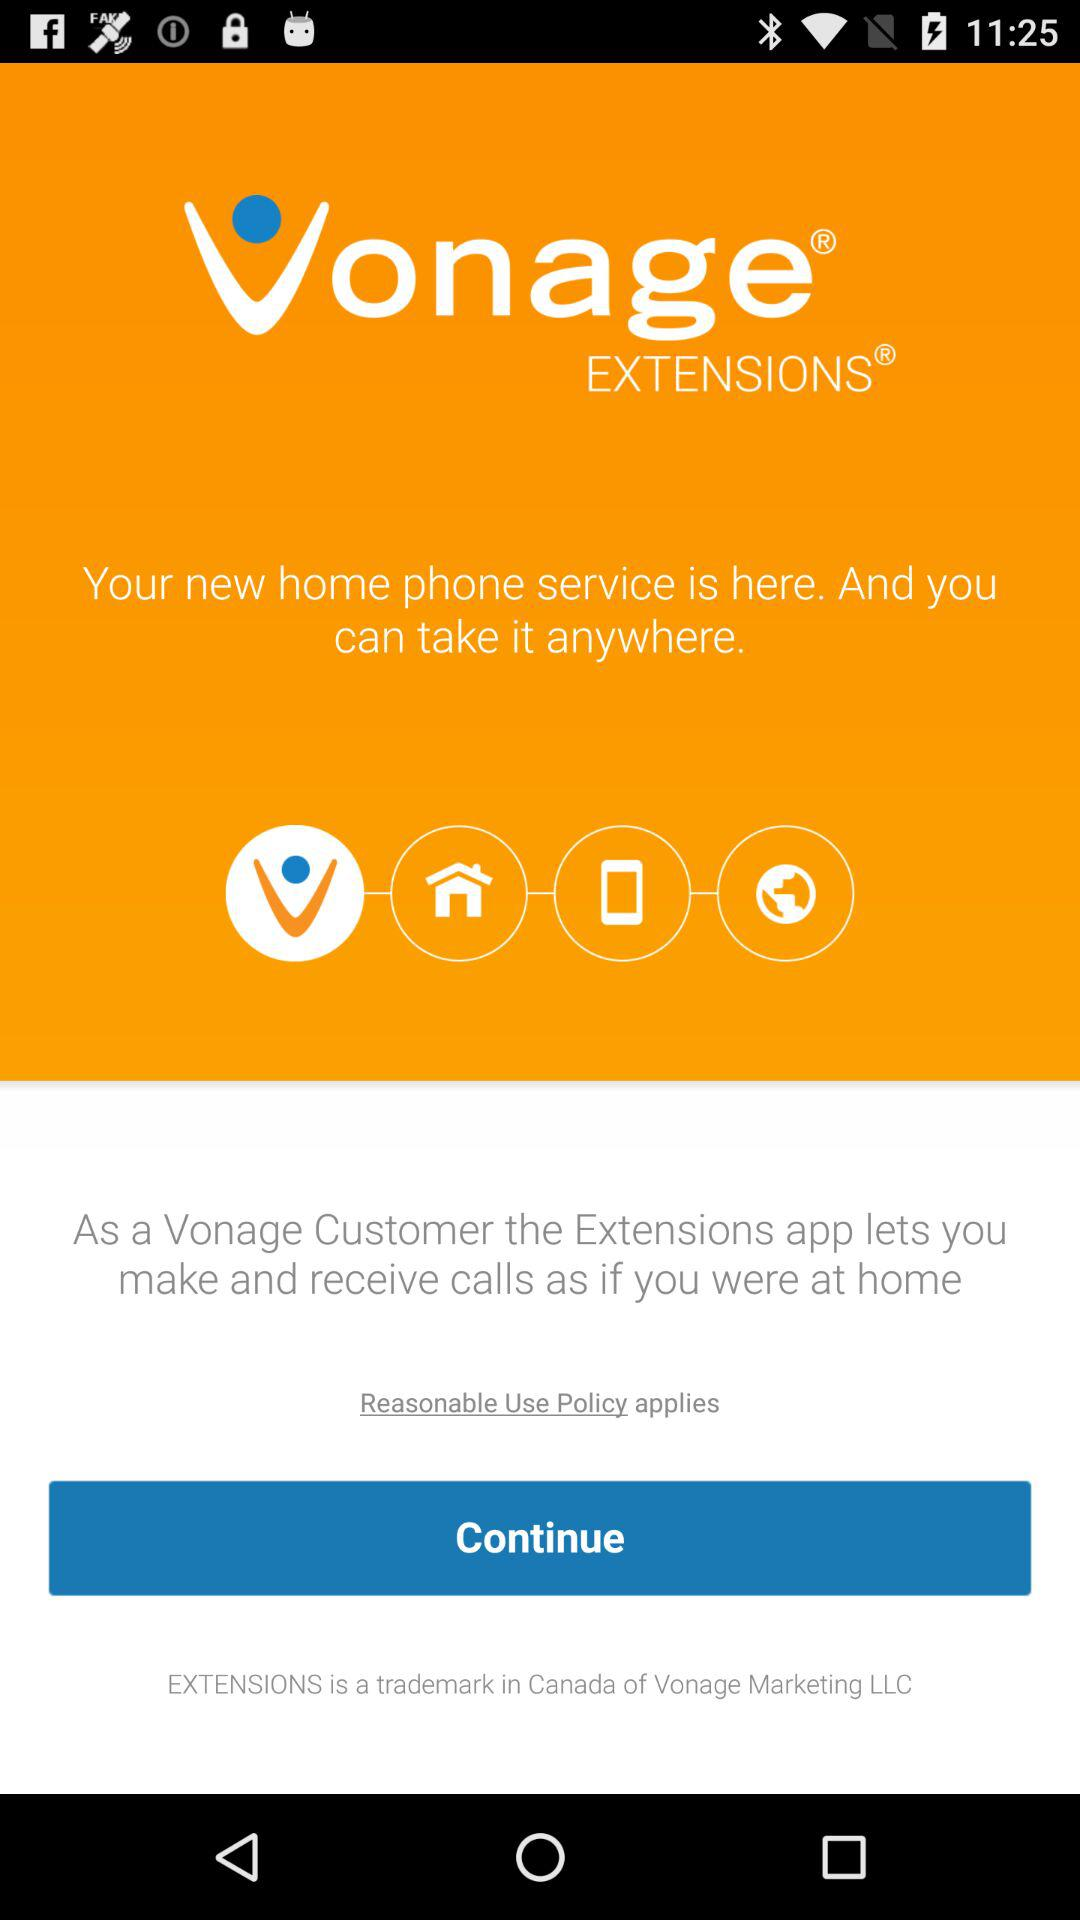What is the application name? The application name is "Vonage EXTENSIONS". 